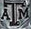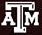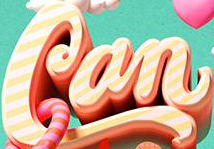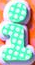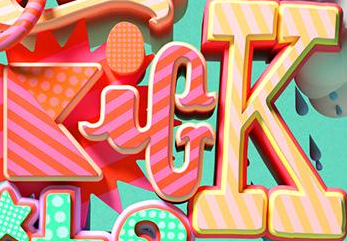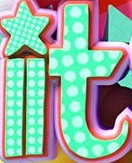What words can you see in these images in sequence, separated by a semicolon? ATM; ATM; Can; i; KicK; it 